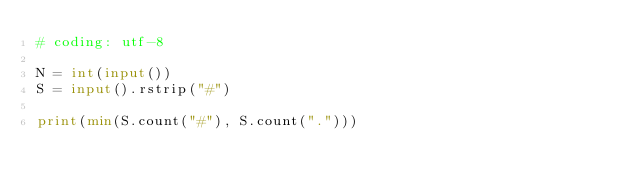<code> <loc_0><loc_0><loc_500><loc_500><_Python_># coding: utf-8

N = int(input())
S = input().rstrip("#")

print(min(S.count("#"), S.count(".")))</code> 